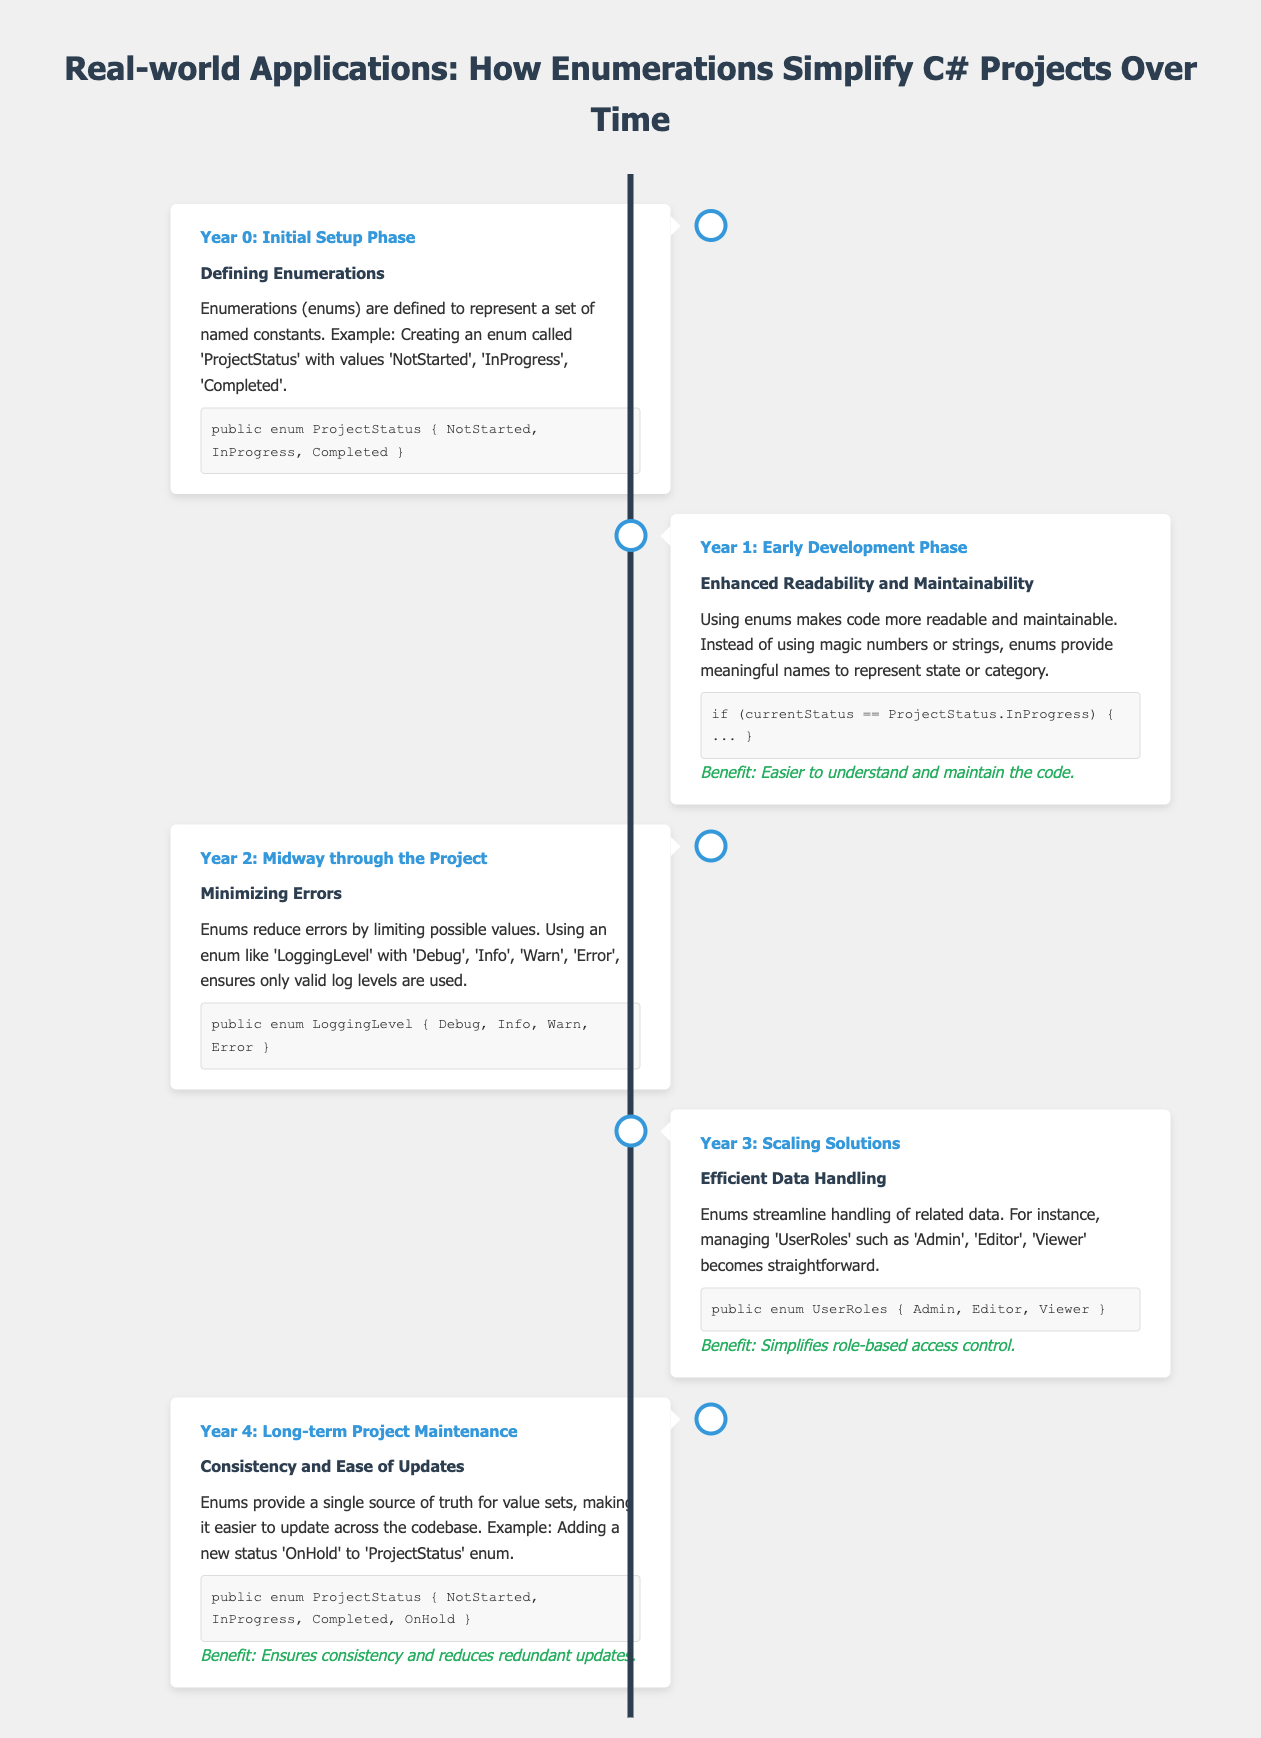What is the title of the document? The title of the document is presented at the top of the infographic, summarizing the theme.
Answer: Real-world Applications: How Enumerations Simplify C# Projects Over Time What year is associated with defining enumerations? The timeline indicates the specific year activities took place, showing a chronological order.
Answer: Year 0 What enum represents project statuses? The details specify the enum created to track the status of a project, showcasing named constants.
Answer: ProjectStatus Which enum is mentioned to minimize errors? The document specifies an enum designed to limit values and enhance correctness in logging.
Answer: LoggingLevel What benefit is highlighted for using enums in terms of readability? The timeline emphasizes the improvements in clarity and maintenance achieved through enums.
Answer: Easier to understand and maintain the code In which year is efficient data handling discussed? The document mentions specific phases of project development, including when data management becomes simpler.
Answer: Year 3 What new status is added to the ProjectStatus enum? The content describes updates to enums over time, reflecting how the project evolves.
Answer: OnHold Which user roles are included in the UserRoles enum? The timeline outlines the specific roles addressed within the user management system.
Answer: Admin, Editor, Viewer What phase emphasizes consistency and ease of updates? The timeline categorizes the project progression into distinct phases, highlighting long-term maintenance advantages.
Answer: Year 4 